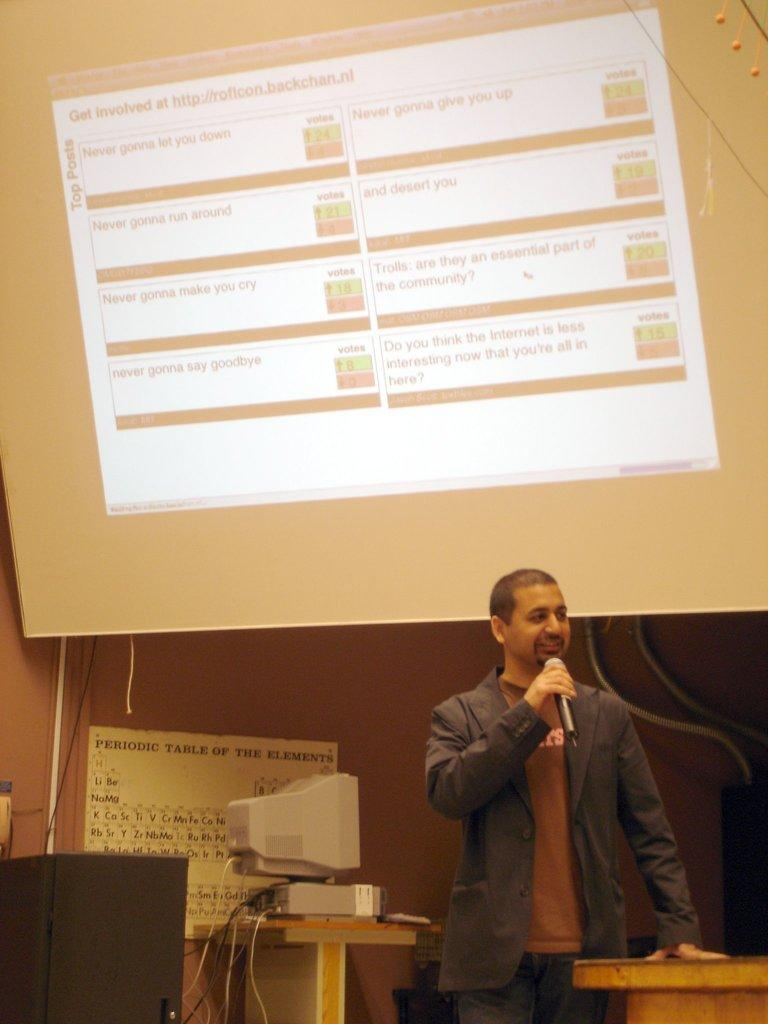What is the man in the image holding? The man is holding a microphone. What type of furniture can be seen in the image? There are tables in the image. What electronic device is present in the image? There is a monitor in the image. What can be seen in the background of the image? There is a screen and a wall in the background of the image. What type of marble is visible on the floor in the image? There is no marble visible on the floor in the image. Is the man in the image playing a guitar? There is no guitar present in the image; the man is holding a microphone. 